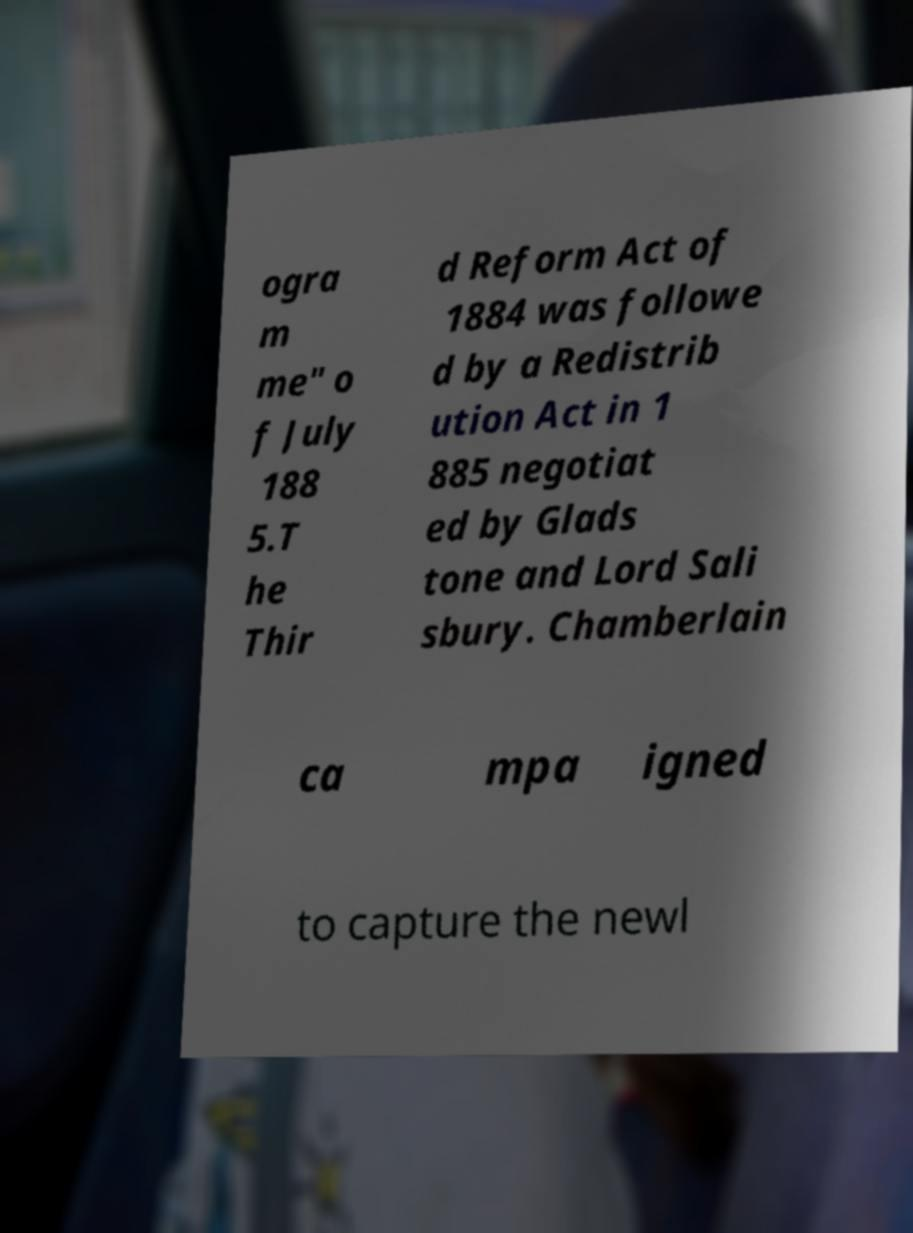Please identify and transcribe the text found in this image. ogra m me" o f July 188 5.T he Thir d Reform Act of 1884 was followe d by a Redistrib ution Act in 1 885 negotiat ed by Glads tone and Lord Sali sbury. Chamberlain ca mpa igned to capture the newl 